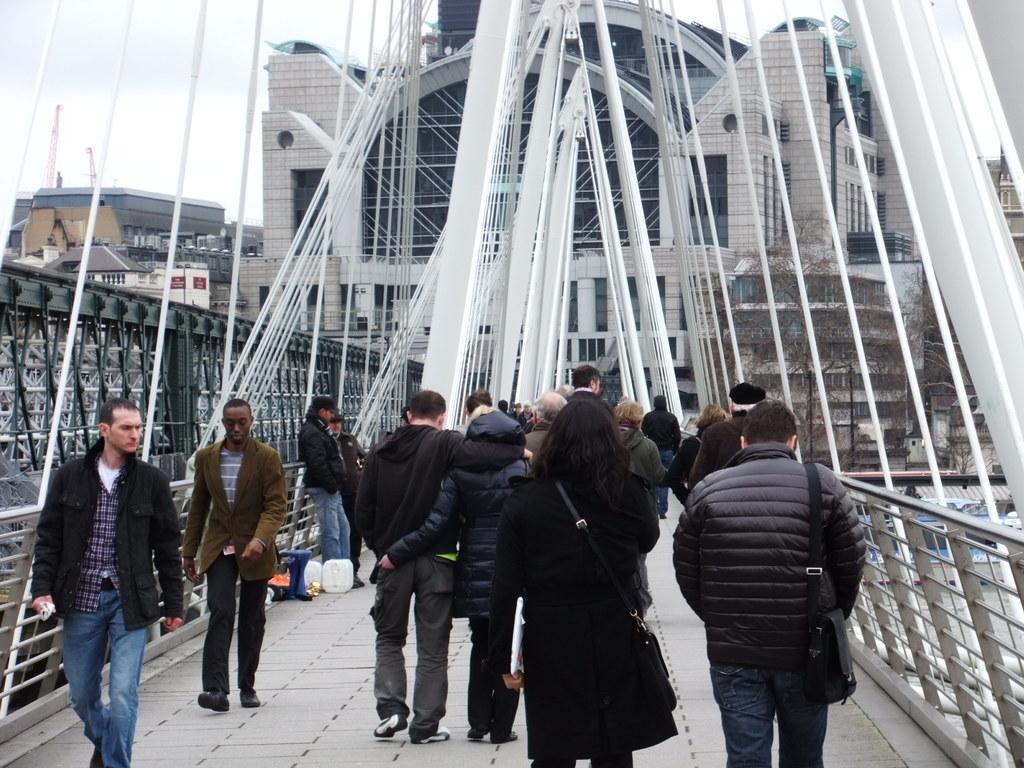Describe this image in one or two sentences. In this picture I can see buildings and few people walking on the bridge and few of them were bags and I can see couple of towers and a cloudy sky. 